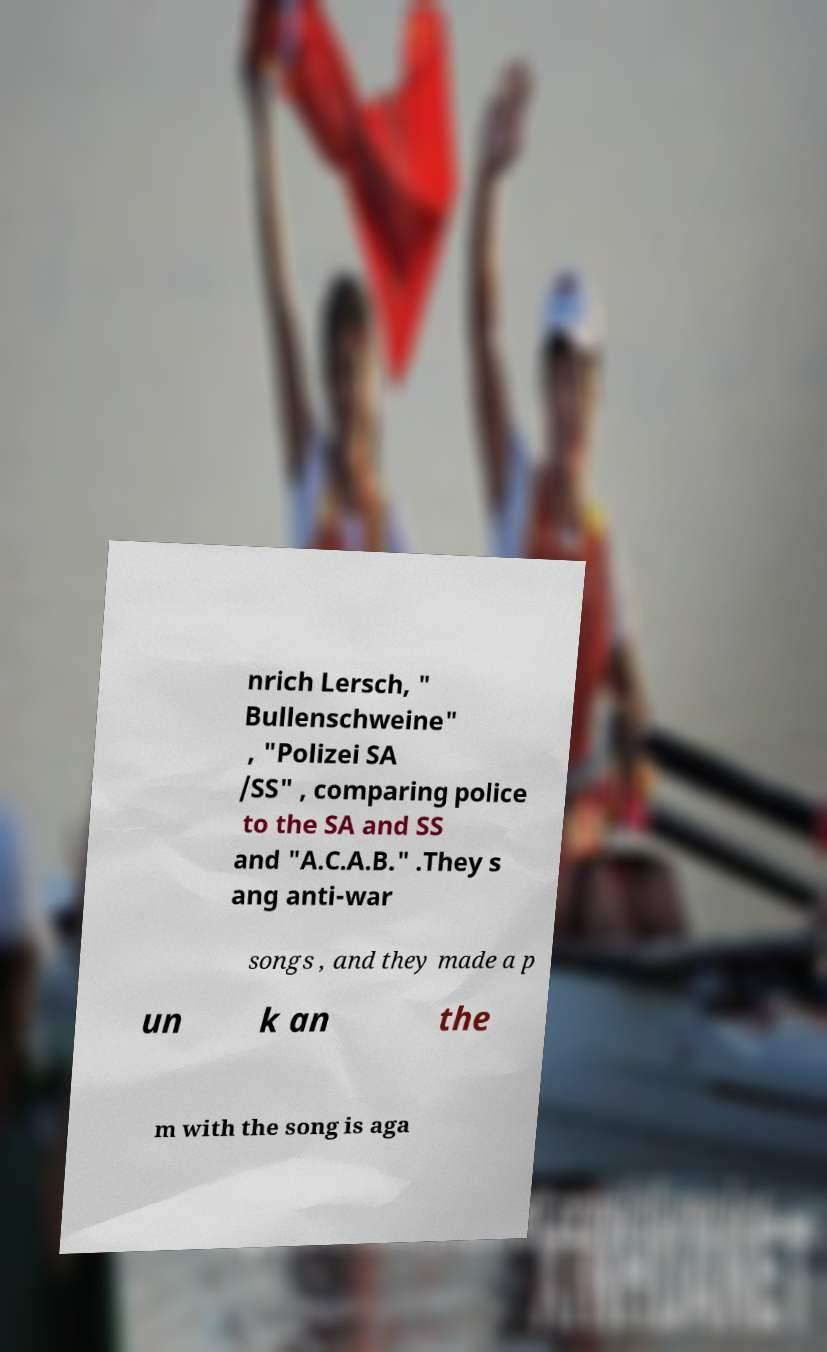Could you extract and type out the text from this image? nrich Lersch, " Bullenschweine" , "Polizei SA /SS" , comparing police to the SA and SS and "A.C.A.B." .They s ang anti-war songs , and they made a p un k an the m with the song is aga 